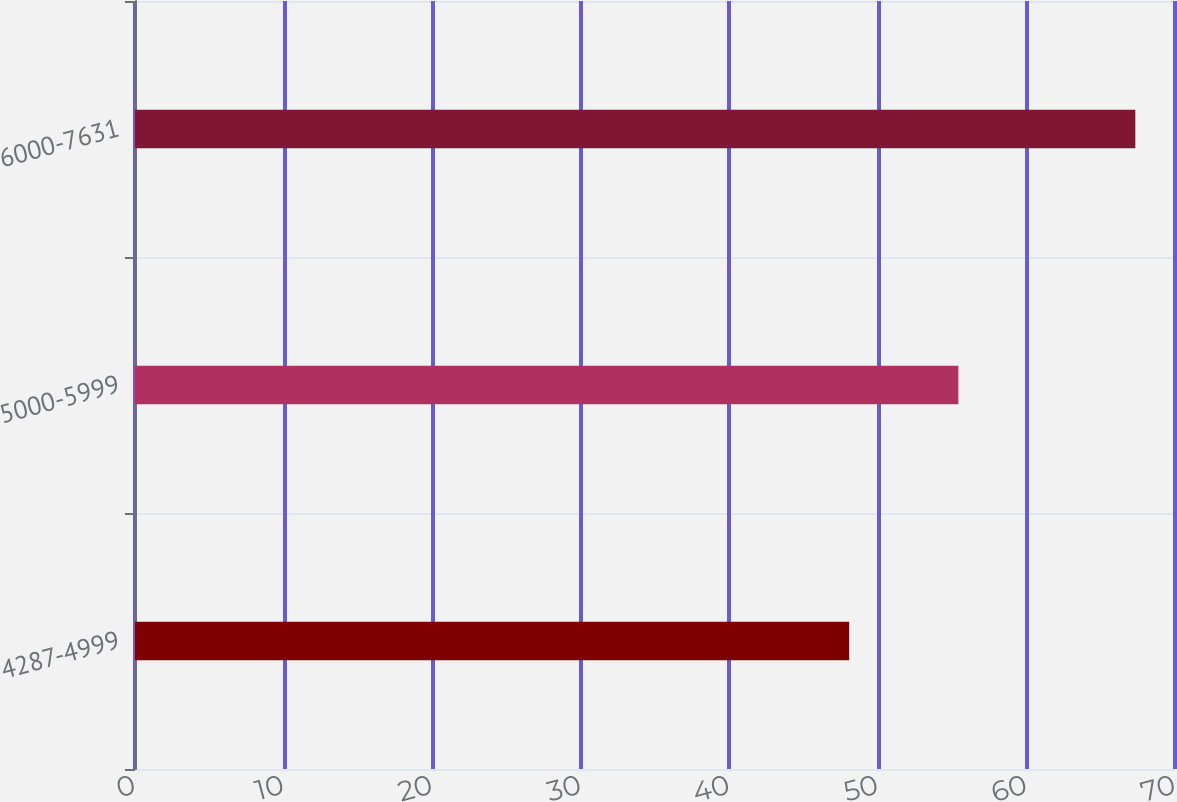Convert chart. <chart><loc_0><loc_0><loc_500><loc_500><bar_chart><fcel>4287-4999<fcel>5000-5999<fcel>6000-7631<nl><fcel>48.07<fcel>55.42<fcel>67.33<nl></chart> 